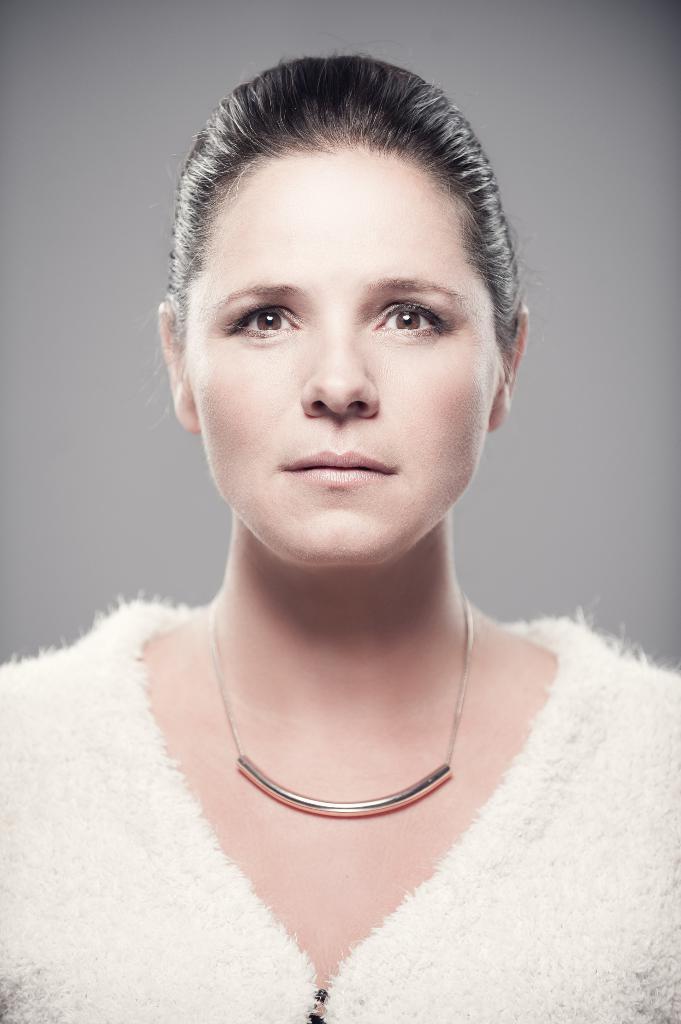Could you give a brief overview of what you see in this image? In this image I can see there is a woman standing, she is wearing a white dress, necklace and in the background I can see there is an ash color surface. 